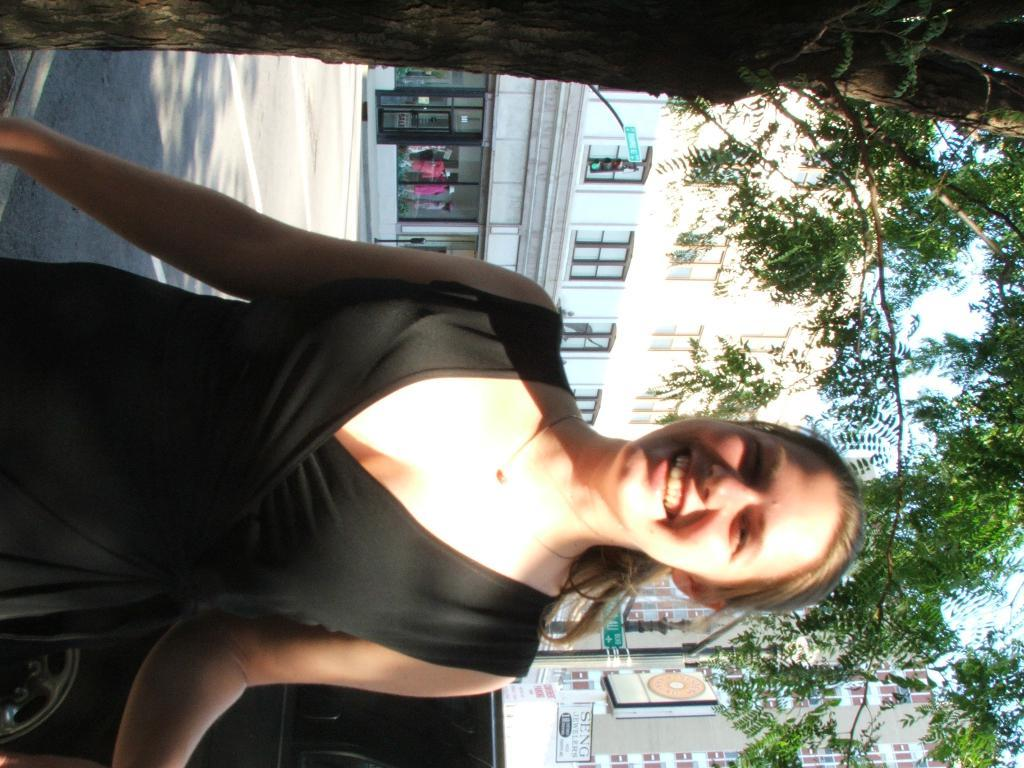Who is present in the image? There is a woman in the image. What is the woman wearing? The woman is wearing a black dress. What expression does the woman have? The woman is smiling. What type of plant can be seen in the image? There is a tree in the image. What mode of transportation is visible in the image? There is a car in the image. What type of structure is present in the image? There is a pole with sign boards in the image. What type of man-made structures can be seen in the image? There are buildings in the image. What type of pathway is visible in the image? There is a road in the image. What type of breakfast is the woman eating in the image? There is no breakfast visible in the image; the woman is not eating anything. What type of needle is being used by the woman in the image? There is no needle present in the image. What type of duck can be seen in the image? There is no duck present in the image. 